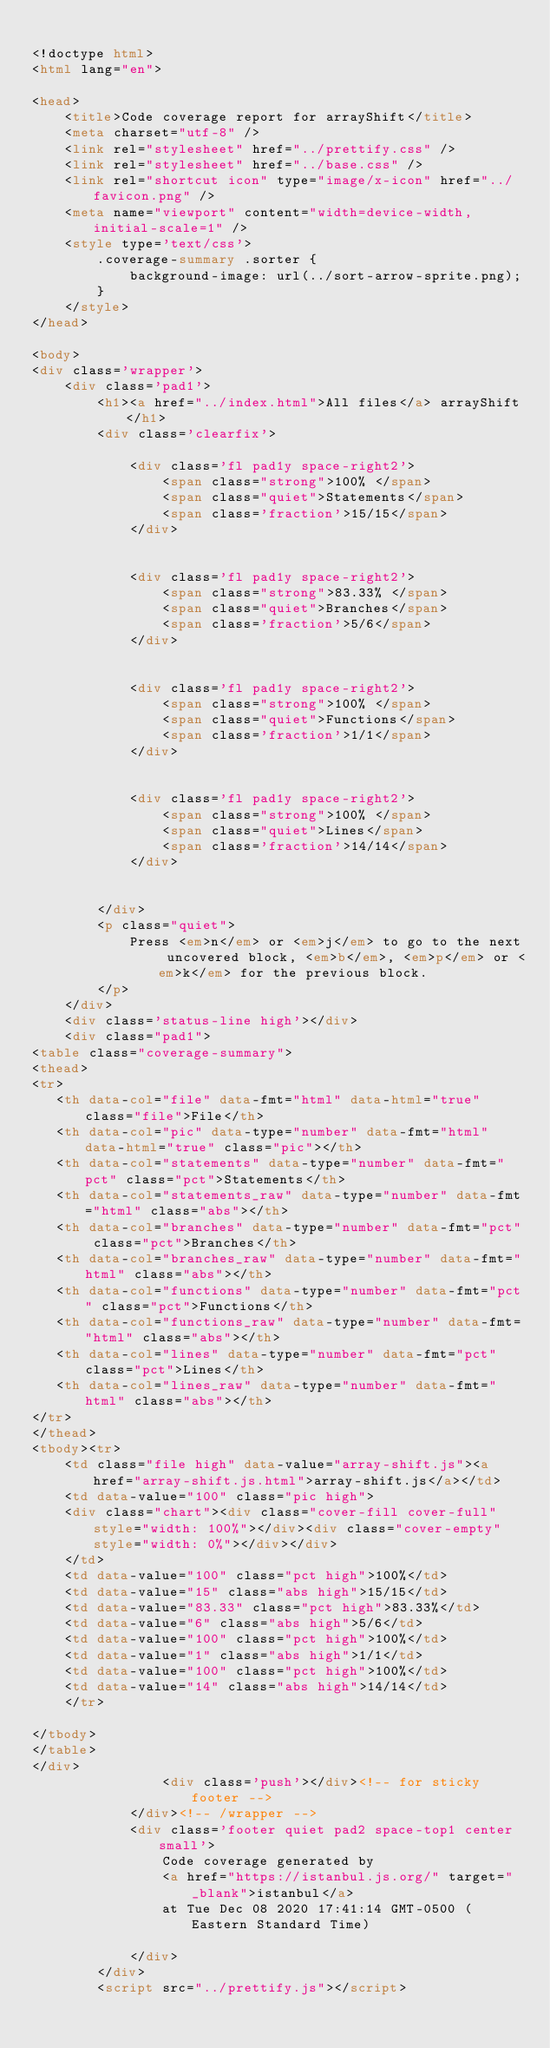<code> <loc_0><loc_0><loc_500><loc_500><_HTML_>
<!doctype html>
<html lang="en">

<head>
    <title>Code coverage report for arrayShift</title>
    <meta charset="utf-8" />
    <link rel="stylesheet" href="../prettify.css" />
    <link rel="stylesheet" href="../base.css" />
    <link rel="shortcut icon" type="image/x-icon" href="../favicon.png" />
    <meta name="viewport" content="width=device-width, initial-scale=1" />
    <style type='text/css'>
        .coverage-summary .sorter {
            background-image: url(../sort-arrow-sprite.png);
        }
    </style>
</head>
    
<body>
<div class='wrapper'>
    <div class='pad1'>
        <h1><a href="../index.html">All files</a> arrayShift</h1>
        <div class='clearfix'>
            
            <div class='fl pad1y space-right2'>
                <span class="strong">100% </span>
                <span class="quiet">Statements</span>
                <span class='fraction'>15/15</span>
            </div>
        
            
            <div class='fl pad1y space-right2'>
                <span class="strong">83.33% </span>
                <span class="quiet">Branches</span>
                <span class='fraction'>5/6</span>
            </div>
        
            
            <div class='fl pad1y space-right2'>
                <span class="strong">100% </span>
                <span class="quiet">Functions</span>
                <span class='fraction'>1/1</span>
            </div>
        
            
            <div class='fl pad1y space-right2'>
                <span class="strong">100% </span>
                <span class="quiet">Lines</span>
                <span class='fraction'>14/14</span>
            </div>
        
            
        </div>
        <p class="quiet">
            Press <em>n</em> or <em>j</em> to go to the next uncovered block, <em>b</em>, <em>p</em> or <em>k</em> for the previous block.
        </p>
    </div>
    <div class='status-line high'></div>
    <div class="pad1">
<table class="coverage-summary">
<thead>
<tr>
   <th data-col="file" data-fmt="html" data-html="true" class="file">File</th>
   <th data-col="pic" data-type="number" data-fmt="html" data-html="true" class="pic"></th>
   <th data-col="statements" data-type="number" data-fmt="pct" class="pct">Statements</th>
   <th data-col="statements_raw" data-type="number" data-fmt="html" class="abs"></th>
   <th data-col="branches" data-type="number" data-fmt="pct" class="pct">Branches</th>
   <th data-col="branches_raw" data-type="number" data-fmt="html" class="abs"></th>
   <th data-col="functions" data-type="number" data-fmt="pct" class="pct">Functions</th>
   <th data-col="functions_raw" data-type="number" data-fmt="html" class="abs"></th>
   <th data-col="lines" data-type="number" data-fmt="pct" class="pct">Lines</th>
   <th data-col="lines_raw" data-type="number" data-fmt="html" class="abs"></th>
</tr>
</thead>
<tbody><tr>
	<td class="file high" data-value="array-shift.js"><a href="array-shift.js.html">array-shift.js</a></td>
	<td data-value="100" class="pic high">
	<div class="chart"><div class="cover-fill cover-full" style="width: 100%"></div><div class="cover-empty" style="width: 0%"></div></div>
	</td>
	<td data-value="100" class="pct high">100%</td>
	<td data-value="15" class="abs high">15/15</td>
	<td data-value="83.33" class="pct high">83.33%</td>
	<td data-value="6" class="abs high">5/6</td>
	<td data-value="100" class="pct high">100%</td>
	<td data-value="1" class="abs high">1/1</td>
	<td data-value="100" class="pct high">100%</td>
	<td data-value="14" class="abs high">14/14</td>
	</tr>

</tbody>
</table>
</div>
                <div class='push'></div><!-- for sticky footer -->
            </div><!-- /wrapper -->
            <div class='footer quiet pad2 space-top1 center small'>
                Code coverage generated by
                <a href="https://istanbul.js.org/" target="_blank">istanbul</a>
                at Tue Dec 08 2020 17:41:14 GMT-0500 (Eastern Standard Time)

            </div>
        </div>
        <script src="../prettify.js"></script></code> 